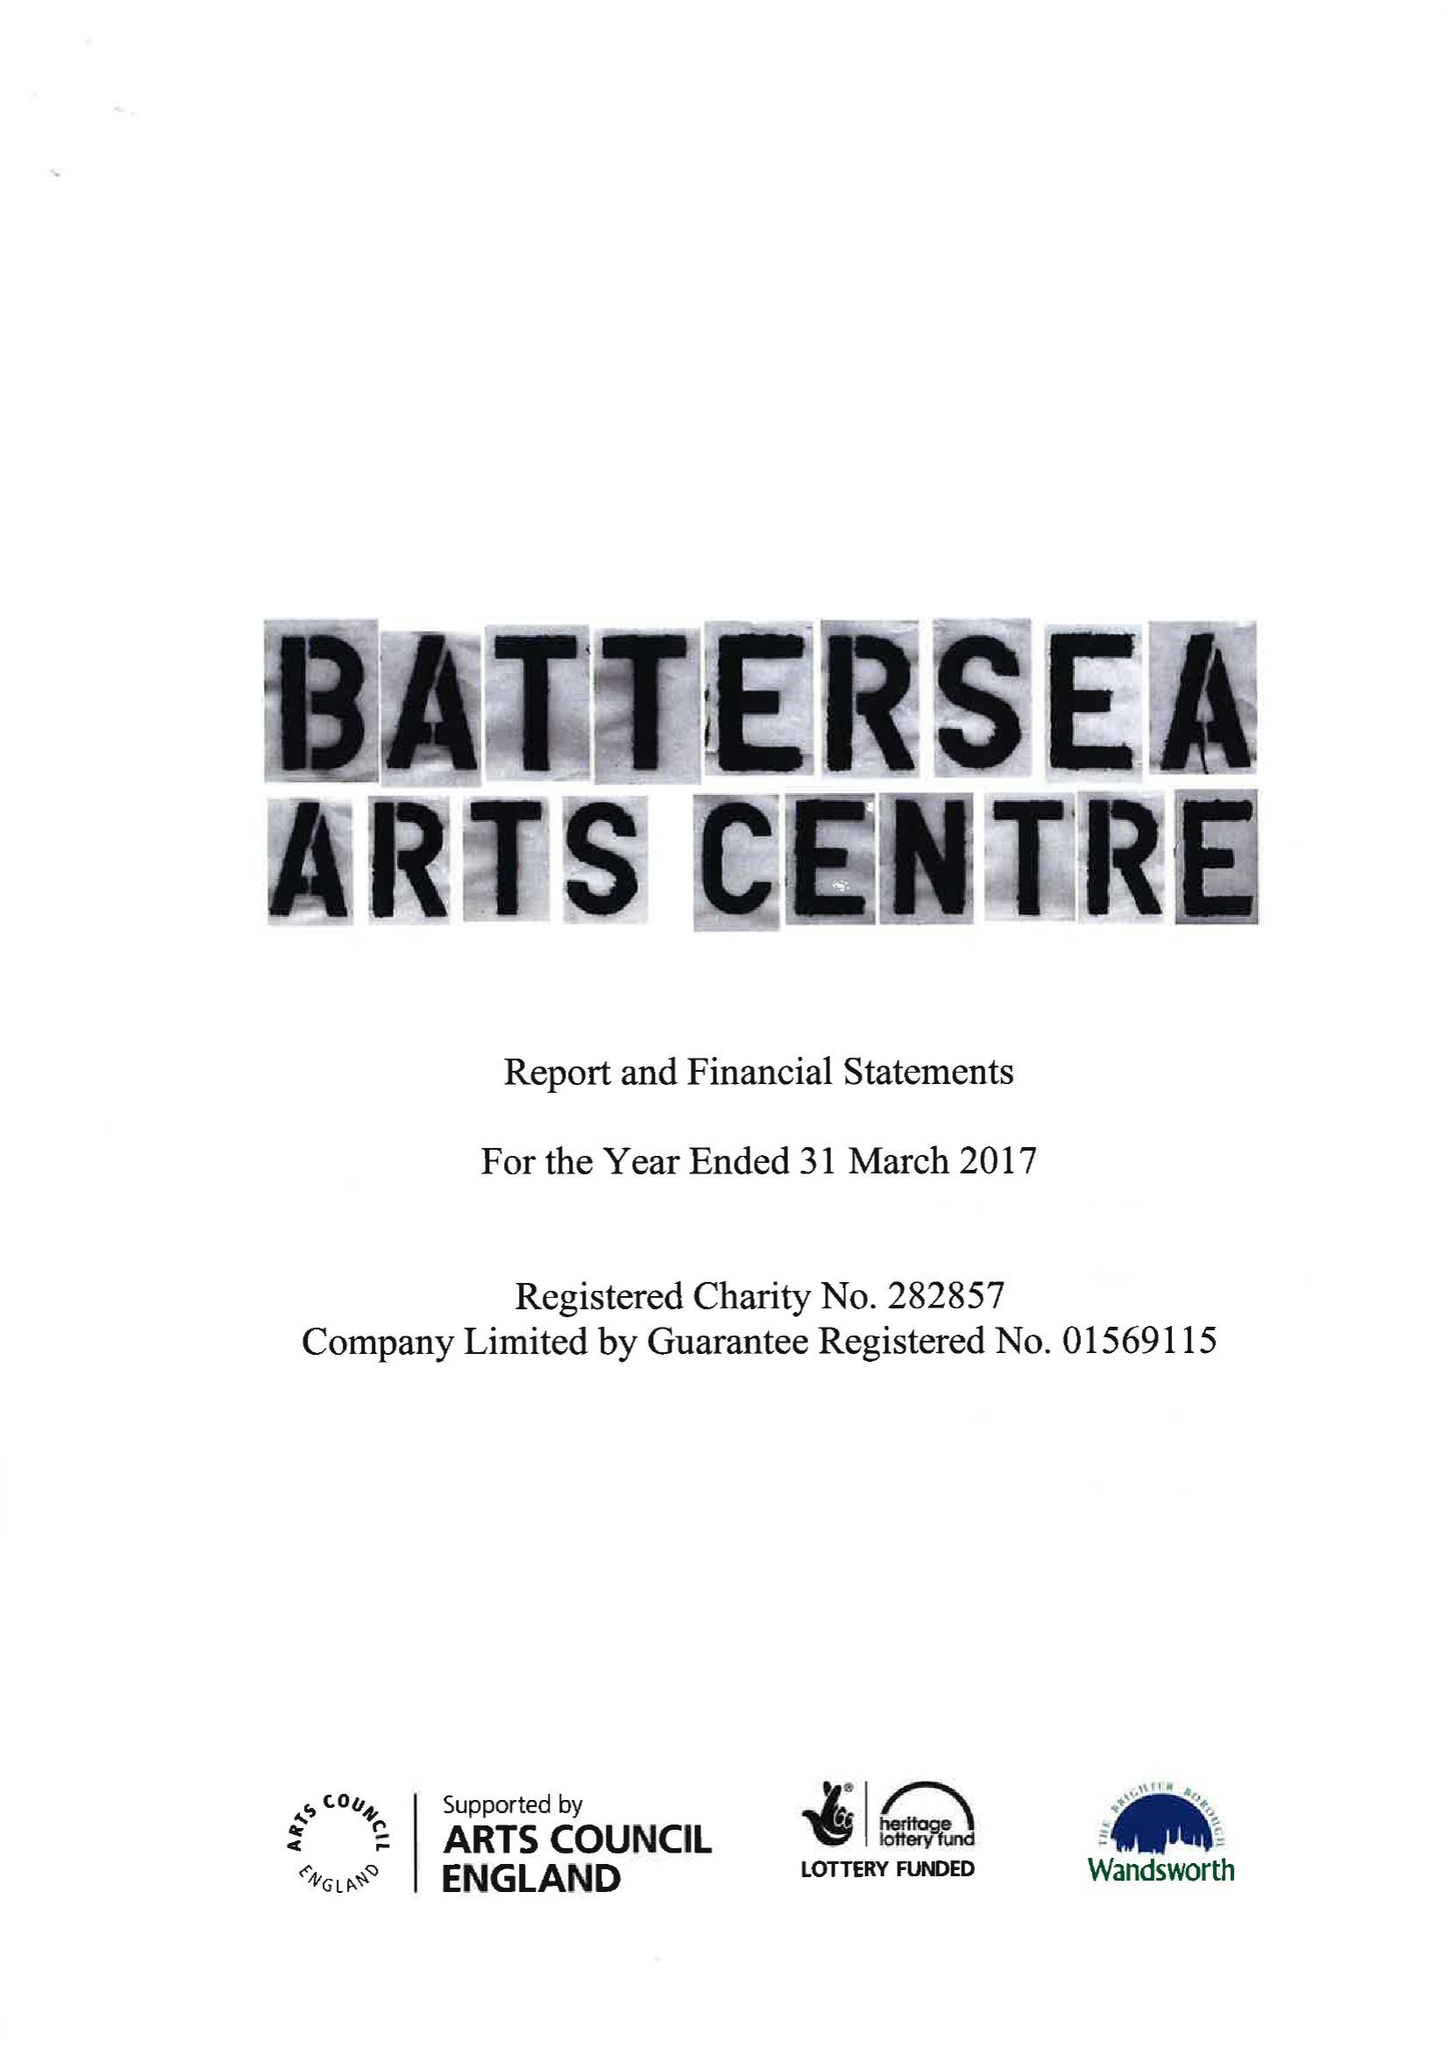What is the value for the report_date?
Answer the question using a single word or phrase. 2017-03-31 